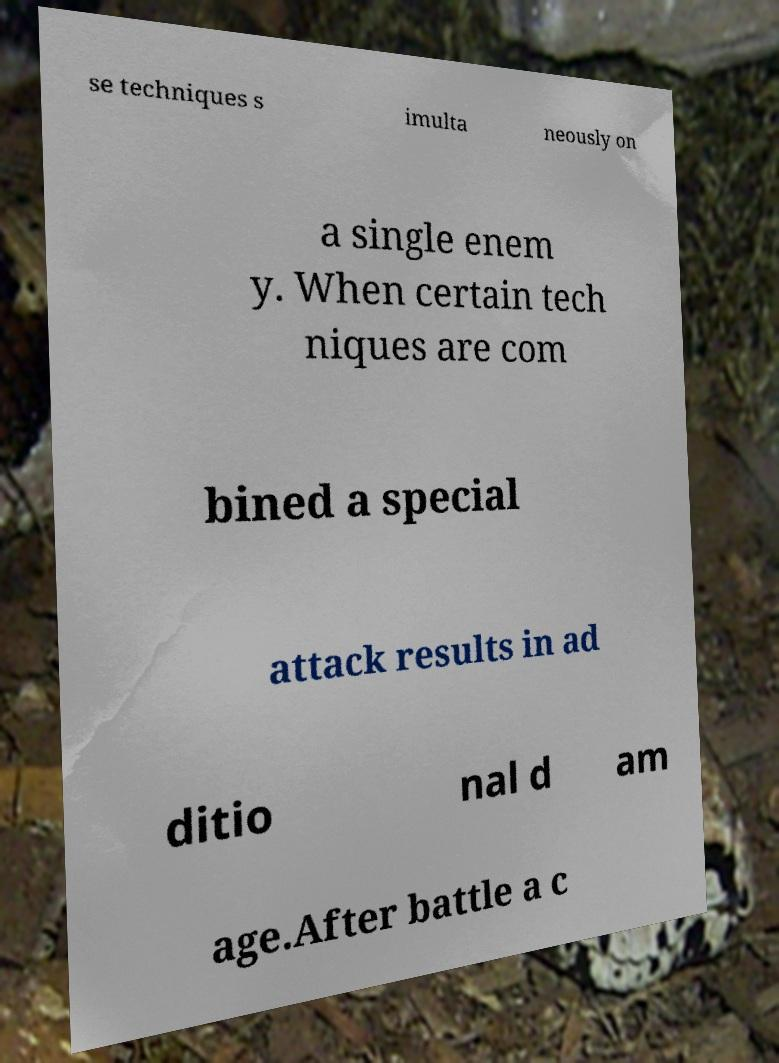Could you extract and type out the text from this image? se techniques s imulta neously on a single enem y. When certain tech niques are com bined a special attack results in ad ditio nal d am age.After battle a c 